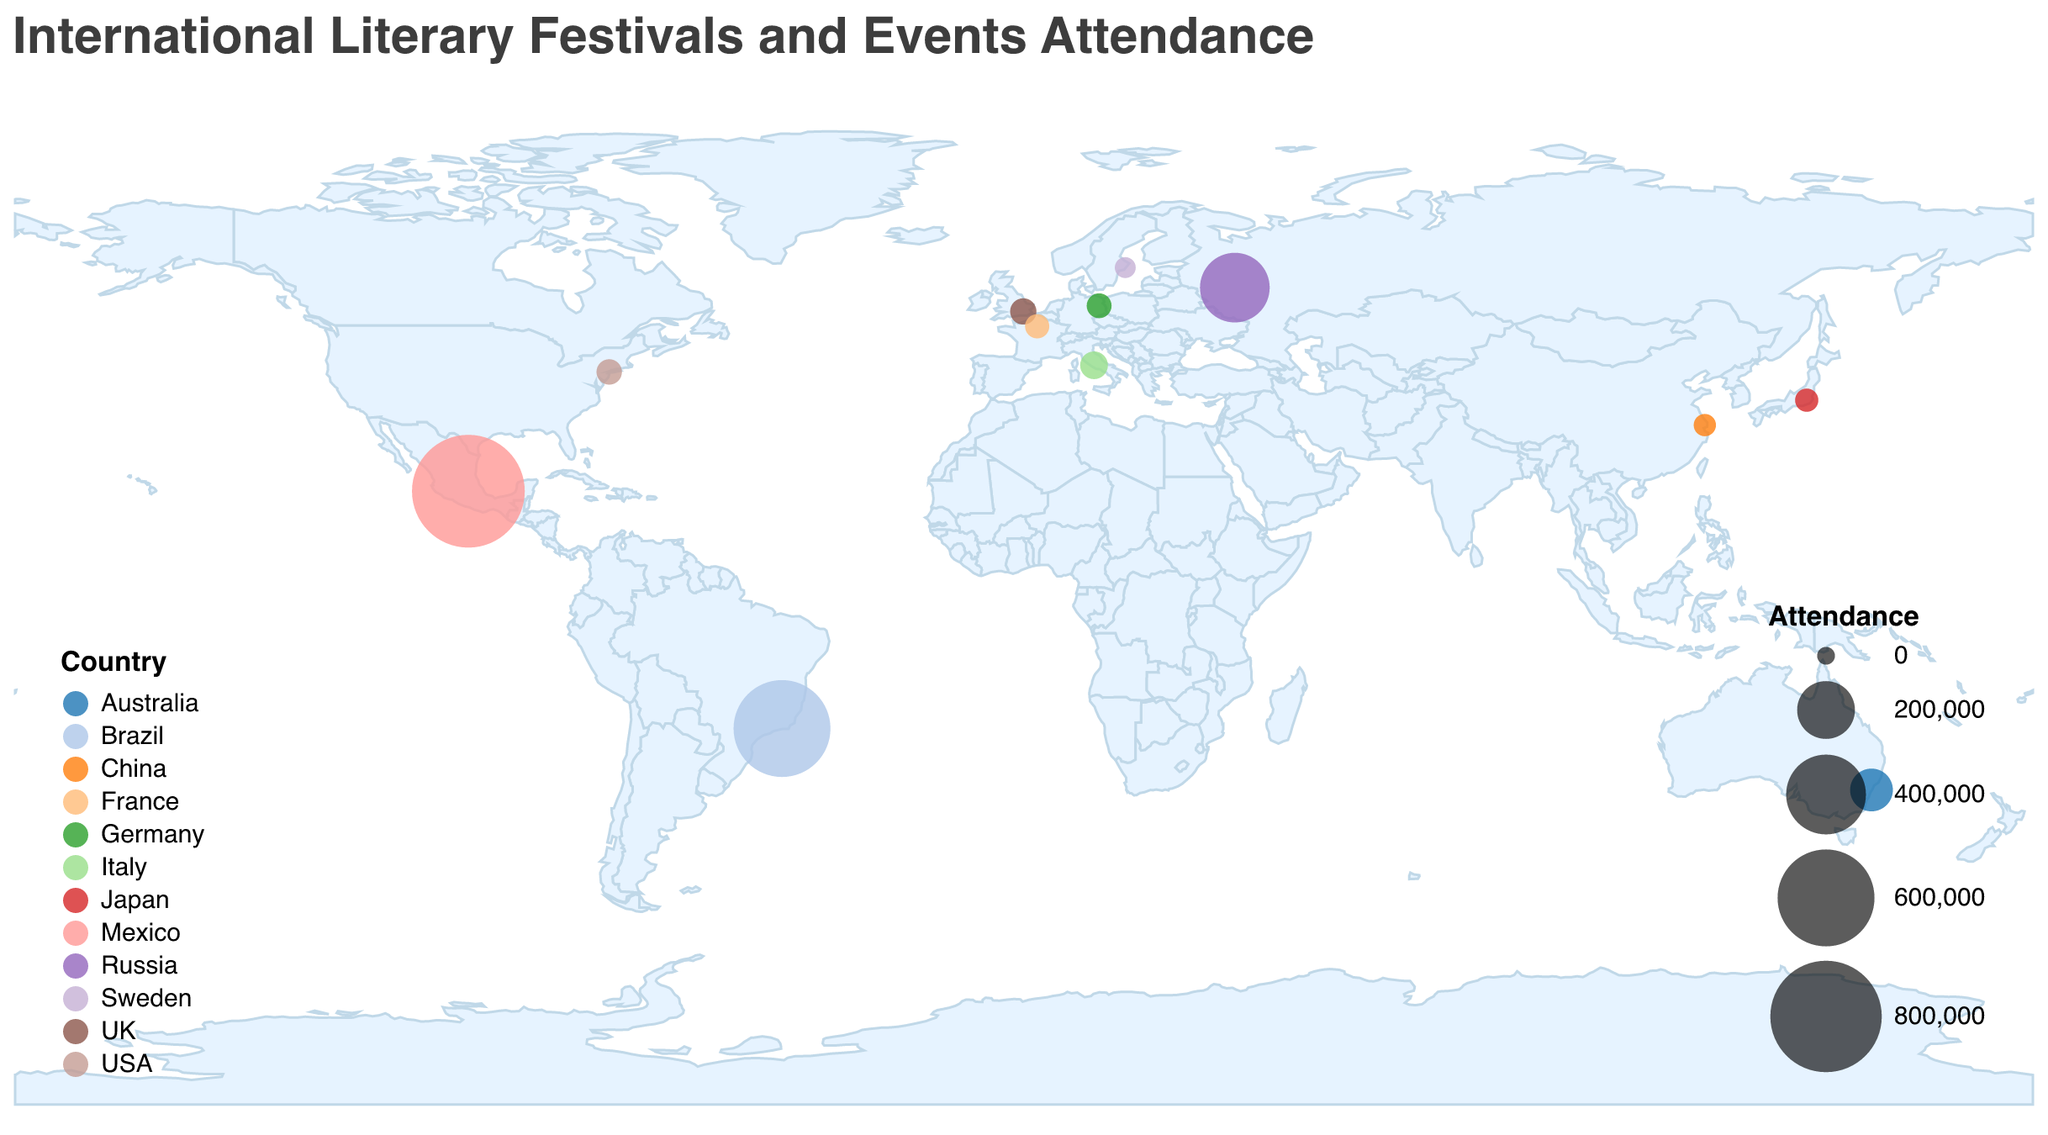What's the title of the plot? The title of the plot is usually displayed prominently at the top of the figure. Here, the title is indicated as "International Literary Festivals and Events Attendance" according to the provided code.
Answer: International Literary Festivals and Events Attendance Which festival has the highest attendance, and where is it located? To find the festival with the highest attendance, look at the size of the circles, as larger circles represent higher attendance. The largest circle on the plot will be for the Guadalajara International Book Fair with 820,000 attendees, located in Mexico.
Answer: Guadalajara International Book Fair, Mexico Which country hosts the Berlin International Literature Festival, and what is its attendance? The tooltip provides the specific festival information when hovering over a data point. By identifying the Berlin International Literature Festival on the map (small circle at Berlin), we see that it is hosted in Germany with an attendance of 20,000.
Answer: Germany, 20,000 How does the attendance of the Tokyo International Literary Festival compare to that of the Stockholm Literature Festival? To compare, look at the respective attendance values indicated in the legend and tooltips. Tokyo International Literary Festival has an attendance of 15,000, whereas Stockholm Literature Festival has an attendance of 8,000. Hence, Tokyo has a higher attendance than Stockholm.
Answer: Tokyo has higher attendance What is the average attendance across all festivals listed? To get the average, sum all the attendance values and then divide by the number of festivals. The attendances are 25,000 (London), 18,000 (Paris), 22,000 (New York), 820,000 (Guadalajara), 100,000 (Sydney), 300,000 (Moscow), 15,000 (Tokyo), 30,000 (Rome), 20,000 (Berlin), 12,000 (Shanghai), 600,000 (Rio de Janeiro), 8,000 (Stockholm). The total is 1,970,000, and there are 12 festivals: 1,970,000 / 12 = 164,166.67
Answer: 164,166.67 Which two festivals have the closest attendance figures, and what are they? By examining the attendance values, the closest figures are Tokyo International Literary Festival (15,000) and Shanghai International Literary Festival (12,000). The difference is the smallest between these two.
Answer: Tokyo International Literary Festival, Shanghai International Literary Festival Which country has the second highest festival attendance, and what is the value? The second largest circle represents the Moscow International Book Fair with an attendance of 300,000, located in Russia. The highest is Guadalajara, and the second highest is Moscow.
Answer: Russia, 300,000 How many festivals have attendance figures above 100,000? Count the number of circles with an attendance greater than 100,000. They are Guadalajara International Book Fair (820,000), Sydney Writers' Festival (100,000), Moscow International Book Fair (300,000), Rio de Janeiro International Book Biennial (600,000). Thus, there are 4 such festivals.
Answer: 4 